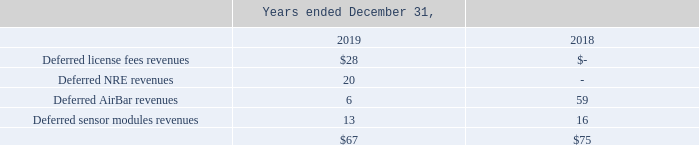Deferred Revenues
Deferred revenues consist primarily of prepayments for license fees, and other products or services for which we have been paid in advance, and earn the revenue when we transfer control of the product or service. Deferred revenues may also include upfront payments for consulting services to be performed in the future, such as non-recurring engineering services.
We defer license fees until we have met all accounting requirements for revenue recognition, which is when a license is made available to a customer and that customer has a right to use the license. Engineering development fee revenues are deferred until engineering services have been completed and accepted by our customers. We defer AirBar and sensor modules revenues until distributors sell the products to their end customers
Under U.S. GAAP, companies may make reasonable aggregations and approximations of returns data to accurately estimate returns. Our AirBar and sensor module returns and warranty experience to date has enabled us to make reasonable returns estimates, which are supported by the fact that our product sales involve homogenous transactions. The reserve for future sales returns is recorded as a reduction of our accounts receivable and revenue and was insignificant as of December 31, 2019 and 2018.
The following table presents our deferred revenues by source (in thousands);
How much was the deferred AirBar revenues for the year ended December 31, 2018, and 2019, respectively?
Answer scale should be: thousand. 16, 13. What is the proportion of deferred license fees and NRE revenues over total deferred revenues for the year ended December 31, 2019? (28+20)/67 
Answer: 0.72. What is the percentage change of deferred sensor module revenues from 2018 to 2019?
Answer scale should be: percent. (13-16)/16 
Answer: -18.75. What are the total deferred revenues for both 2018 and 2019?
Answer scale should be: thousand. $67+$75
Answer: 142. What do deferred revenues primarily consist of?  Prepayments for license fees, and other products or services for which we have been paid in advance, and earn the revenue when we transfer control of the product or service. How does the reserve for future sales returns being recorded? As a reduction of our accounts receivable. 